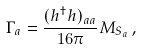Convert formula to latex. <formula><loc_0><loc_0><loc_500><loc_500>\Gamma _ { a } = \frac { ( h ^ { \dagger } h ) _ { a a } } { 1 6 \pi } M _ { S _ { a } } \, ,</formula> 